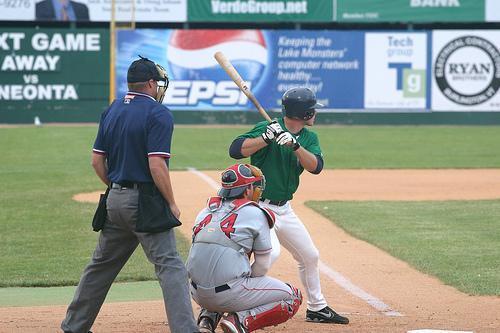How many players are shown?
Give a very brief answer. 2. How many people total are there?
Give a very brief answer. 3. 